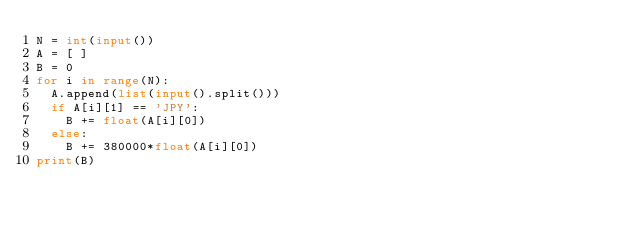Convert code to text. <code><loc_0><loc_0><loc_500><loc_500><_Python_>N = int(input())
A = [ ]
B = 0
for i in range(N):
  A.append(list(input().split()))
  if A[i][1] == 'JPY':
    B += float(A[i][0])
  else:
    B += 380000*float(A[i][0])
print(B)</code> 